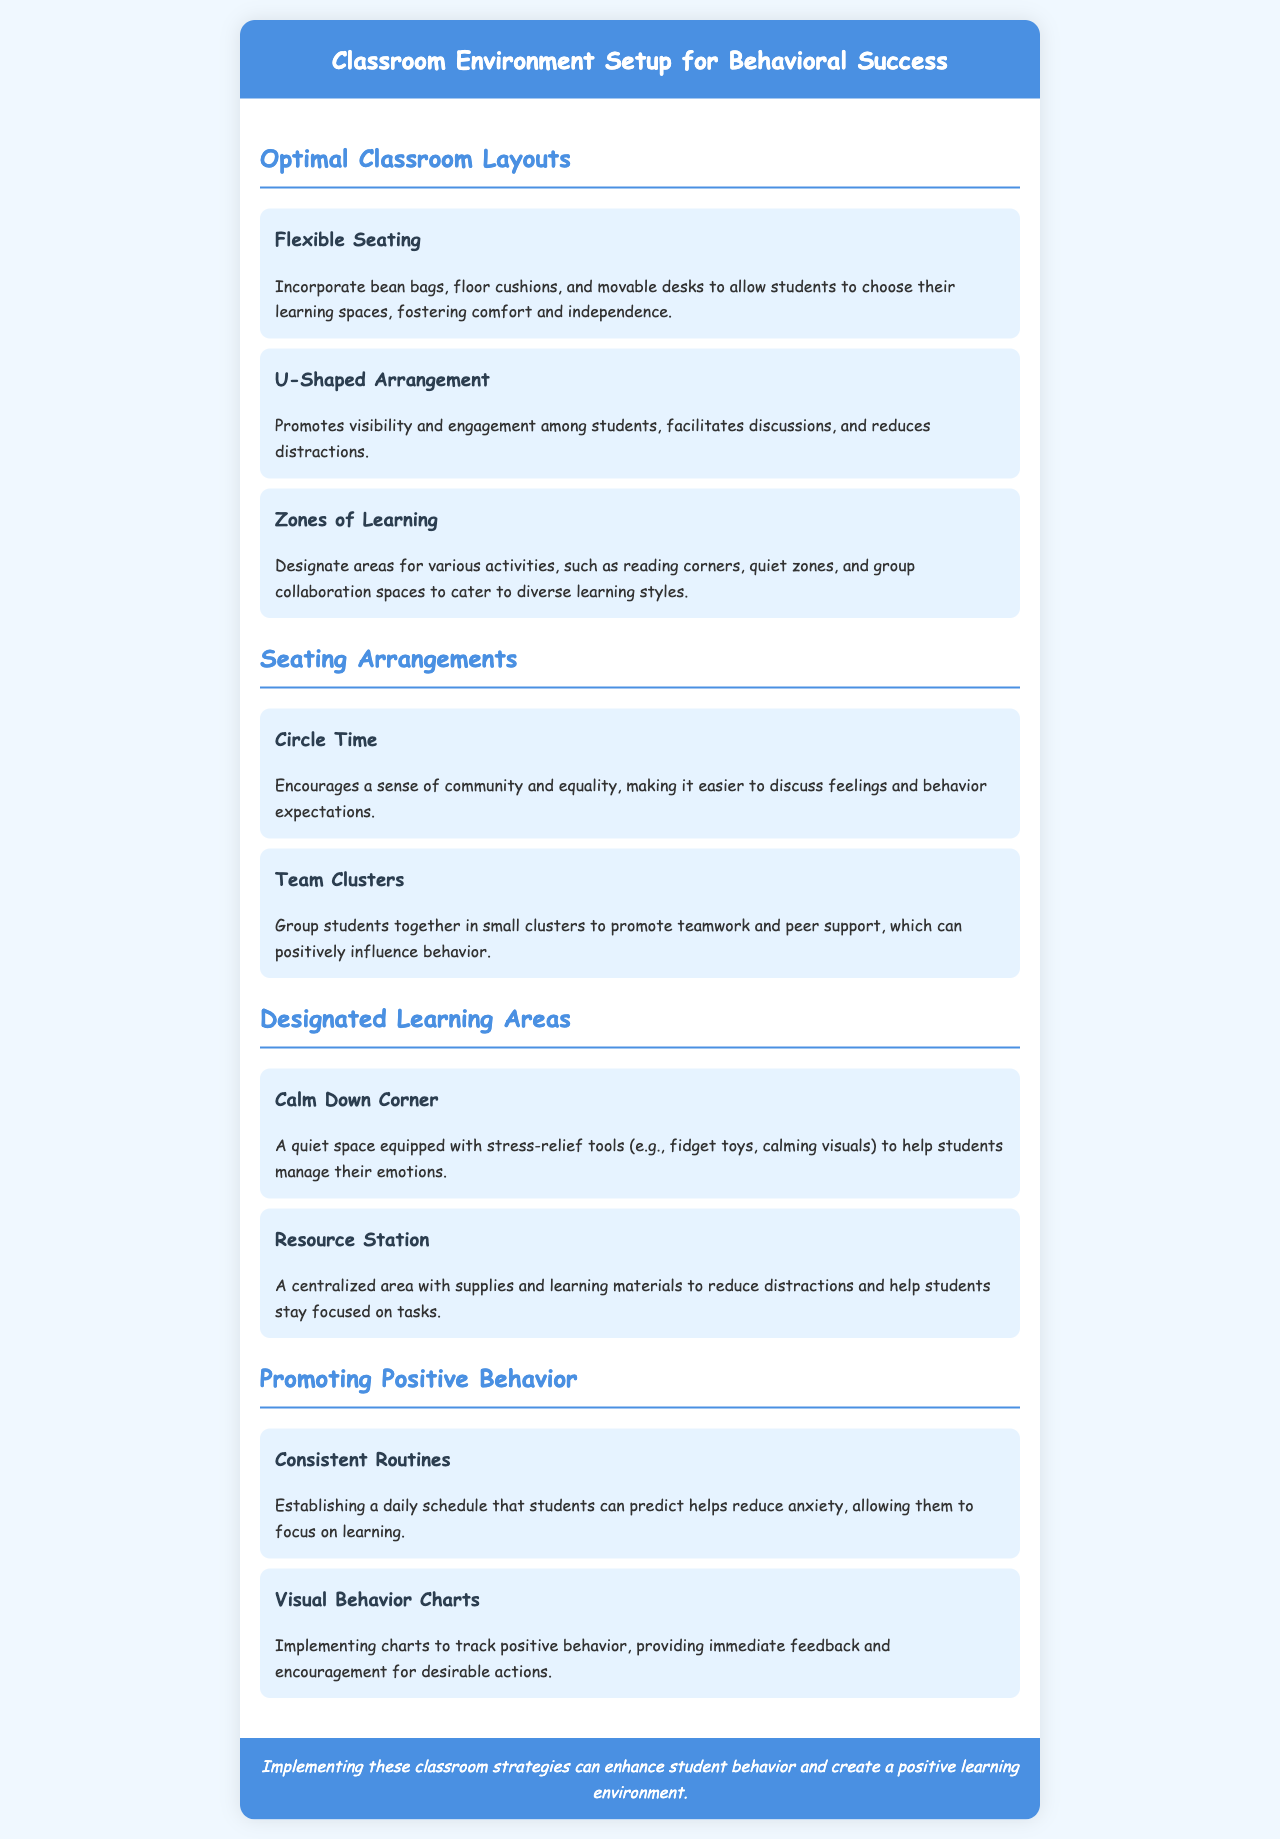What is the focus of the brochure? The title clearly indicates that the brochure focuses on setting up a classroom environment for behavioral success.
Answer: Classroom Environment Setup for Behavioral Success What is one type of seating arrangement mentioned? The specific types of seating arrangements are listed in the "Seating Arrangements" section.
Answer: Circle Time What is the purpose of a Calm Down Corner? The description under "Calm Down Corner" explains its function in managing emotions.
Answer: Help students manage their emotions Which layout promotes visibility and engagement? The "U-Shaped Arrangement" is described as facilitating discussions and visibility.
Answer: U-Shaped Arrangement What do visual behavior charts provide? The brochure mentions that these charts help with immediate feedback and encouragement.
Answer: Immediate feedback and encouragement What is one benefit of having flexible seating? The description under "Flexible Seating" indicates that it fosters comfort and independence.
Answer: Fostering comfort and independence How do team clusters influence behavior? The "Team Clusters" item explains the positive impact on teamwork and peer support on behavior.
Answer: Promote teamwork and peer support 